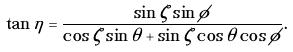Convert formula to latex. <formula><loc_0><loc_0><loc_500><loc_500>\tan \eta = \frac { \sin \zeta \sin \phi } { \cos \zeta \sin \theta + \sin \zeta \cos \theta \cos \phi } .</formula> 